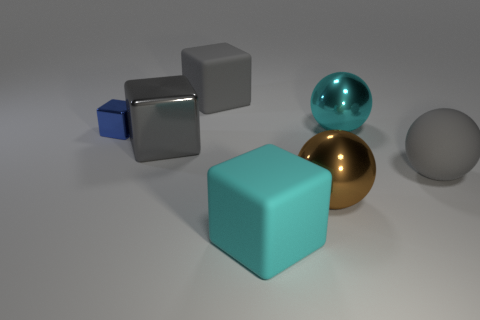Subtract all blue metal blocks. How many blocks are left? 3 Add 1 big gray matte objects. How many objects exist? 8 Subtract all cyan cubes. How many cubes are left? 3 Subtract all blocks. How many objects are left? 3 Subtract 2 blocks. How many blocks are left? 2 Add 4 gray metallic objects. How many gray metallic objects exist? 5 Subtract 0 brown cylinders. How many objects are left? 7 Subtract all gray blocks. Subtract all cyan balls. How many blocks are left? 2 Subtract all green spheres. How many blue cubes are left? 1 Subtract all big gray balls. Subtract all big gray metal things. How many objects are left? 5 